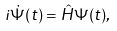<formula> <loc_0><loc_0><loc_500><loc_500>i \dot { \Psi } ( t ) = \hat { H } \Psi ( t ) ,</formula> 